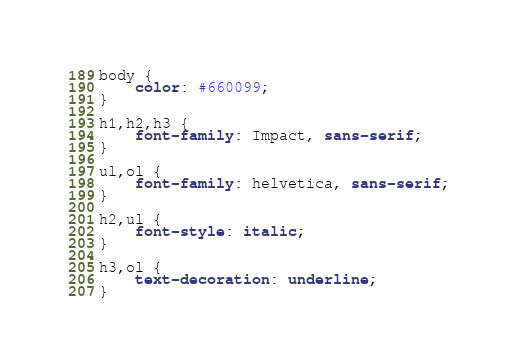Convert code to text. <code><loc_0><loc_0><loc_500><loc_500><_CSS_>body {
    color: #660099;
}
 
h1,h2,h3 {
    font-family: Impact, sans-serif;
}
 
ul,ol {
    font-family: helvetica, sans-serif;
}
 
h2,ul {
    font-style: italic;
}
 
h3,ol {
    text-decoration: underline;
}
</code> 